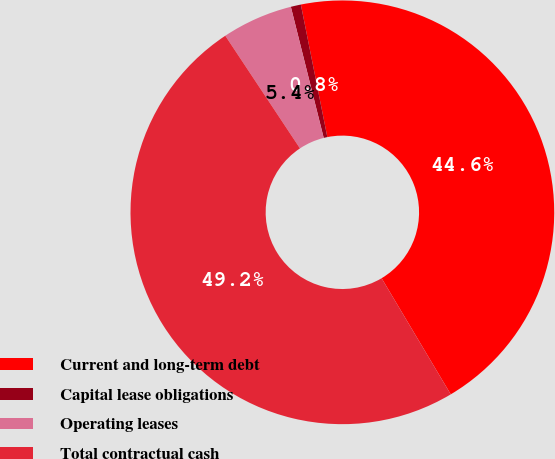<chart> <loc_0><loc_0><loc_500><loc_500><pie_chart><fcel>Current and long-term debt<fcel>Capital lease obligations<fcel>Operating leases<fcel>Total contractual cash<nl><fcel>44.59%<fcel>0.77%<fcel>5.41%<fcel>49.23%<nl></chart> 